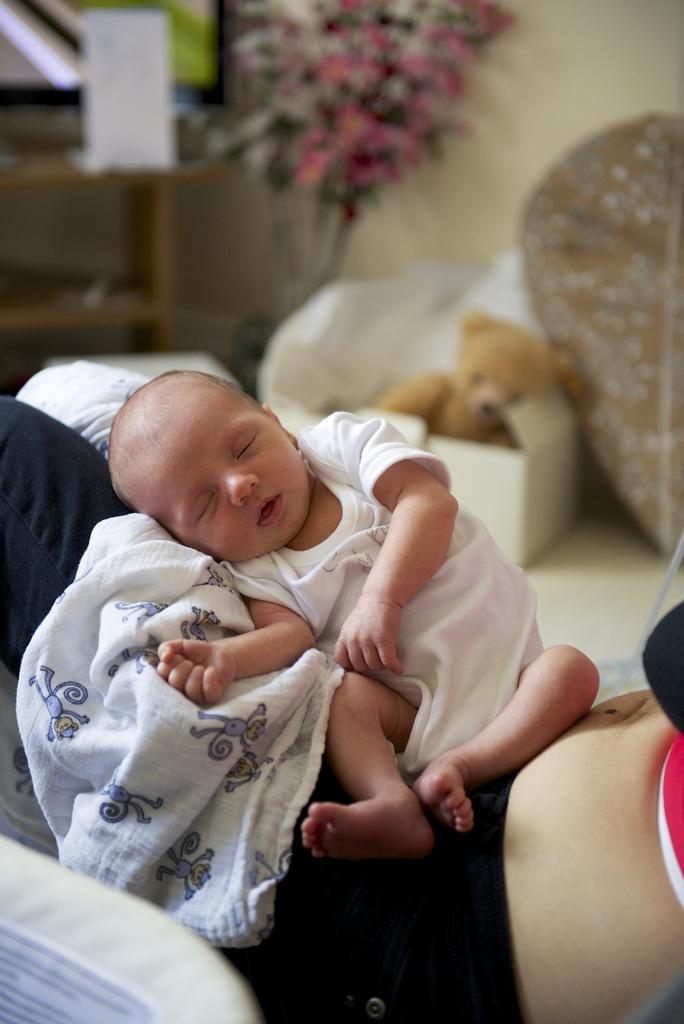What is the main subject of the image? The main subject of the image is a small baby. Where is the baby positioned in the image? The baby is sleeping on the mother's lap. What is the baby wearing in the image? The baby is wearing a black color track. What other objects can be seen in the image? There is a box with a brown color teddy bear and flower pots in the image. What type of clover is growing in the image? There is no clover present in the image. Who needs to give approval for the baby's outfit in the image? The image does not require any approval for the baby's outfit, as it is a photograph and not a decision-making scenario. 